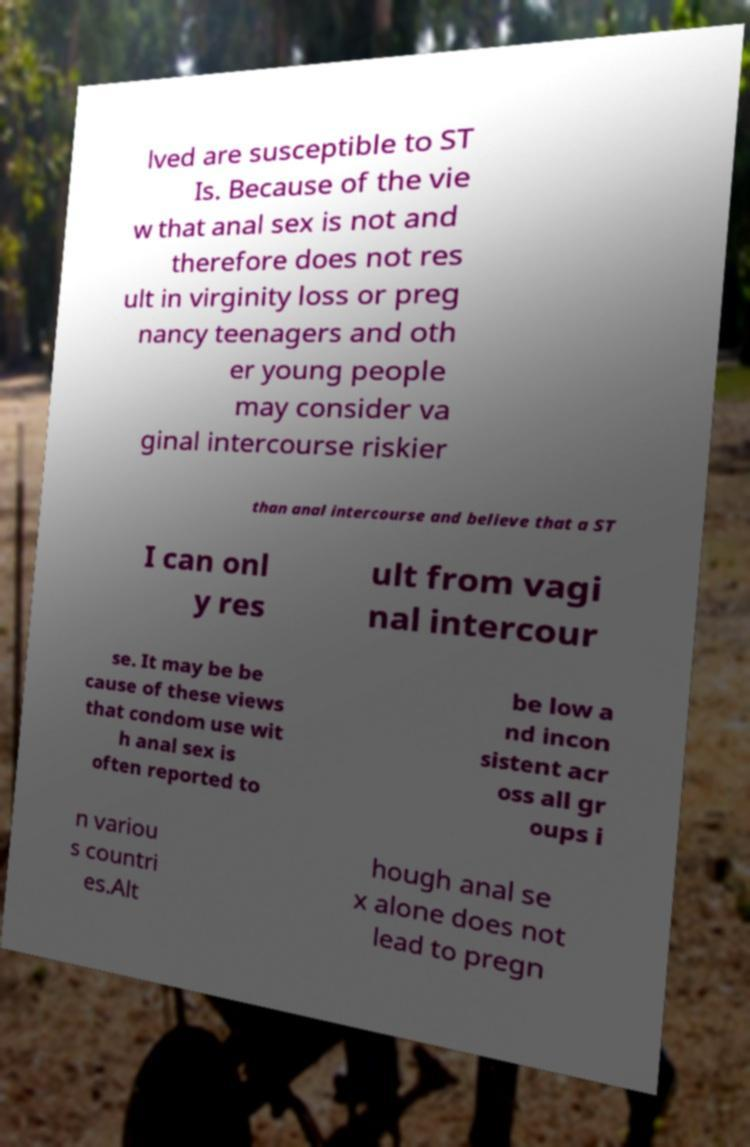Could you assist in decoding the text presented in this image and type it out clearly? lved are susceptible to ST Is. Because of the vie w that anal sex is not and therefore does not res ult in virginity loss or preg nancy teenagers and oth er young people may consider va ginal intercourse riskier than anal intercourse and believe that a ST I can onl y res ult from vagi nal intercour se. It may be be cause of these views that condom use wit h anal sex is often reported to be low a nd incon sistent acr oss all gr oups i n variou s countri es.Alt hough anal se x alone does not lead to pregn 